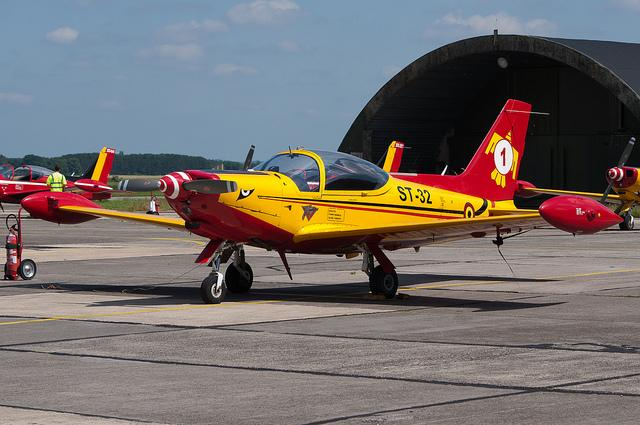What is the purpose of the black structure?

Choices:
A) house planes
B) store tools
C) restaurant
D) police station house planes 